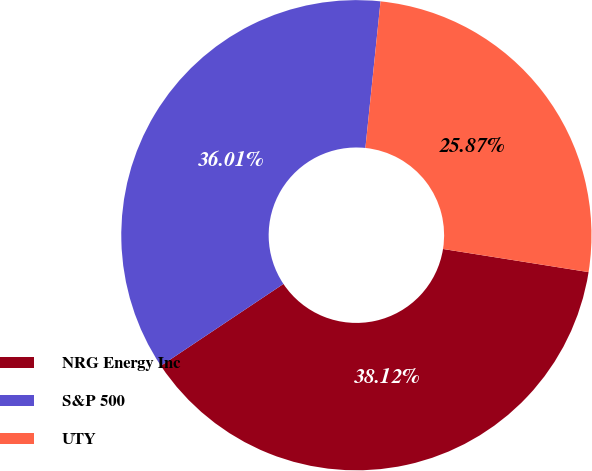<chart> <loc_0><loc_0><loc_500><loc_500><pie_chart><fcel>NRG Energy Inc<fcel>S&P 500<fcel>UTY<nl><fcel>38.12%<fcel>36.01%<fcel>25.87%<nl></chart> 